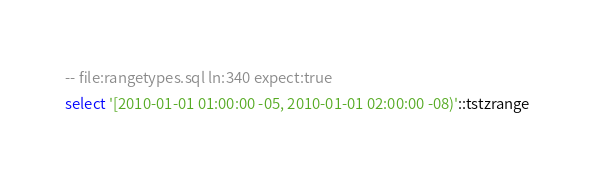<code> <loc_0><loc_0><loc_500><loc_500><_SQL_>-- file:rangetypes.sql ln:340 expect:true
select '[2010-01-01 01:00:00 -05, 2010-01-01 02:00:00 -08)'::tstzrange
</code> 